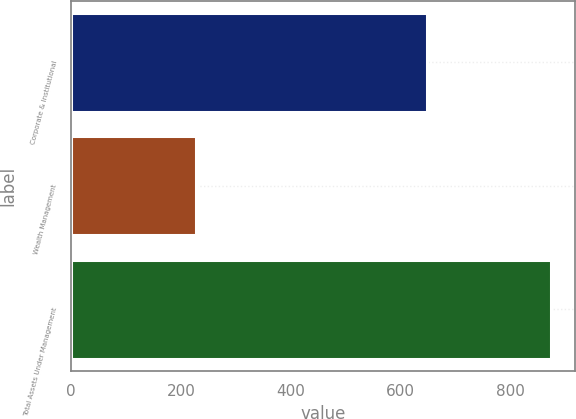<chart> <loc_0><loc_0><loc_500><loc_500><bar_chart><fcel>Corporate & Institutional<fcel>Wealth Management<fcel>Total Assets Under Management<nl><fcel>648<fcel>227.3<fcel>875.3<nl></chart> 